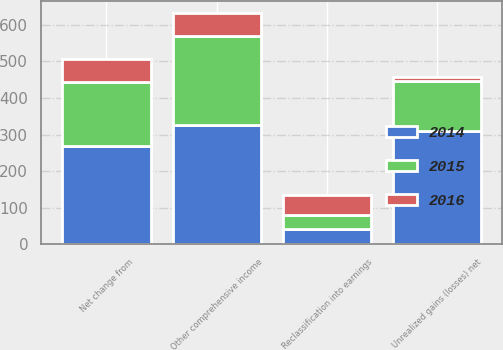Convert chart to OTSL. <chart><loc_0><loc_0><loc_500><loc_500><stacked_bar_chart><ecel><fcel>Unrealized gains (losses) net<fcel>Reclassification into earnings<fcel>Net change from<fcel>Other comprehensive income<nl><fcel>2016<fcel>10<fcel>53<fcel>63<fcel>63<nl><fcel>2015<fcel>136<fcel>39<fcel>175<fcel>244<nl><fcel>2014<fcel>310<fcel>42<fcel>268<fcel>325<nl></chart> 